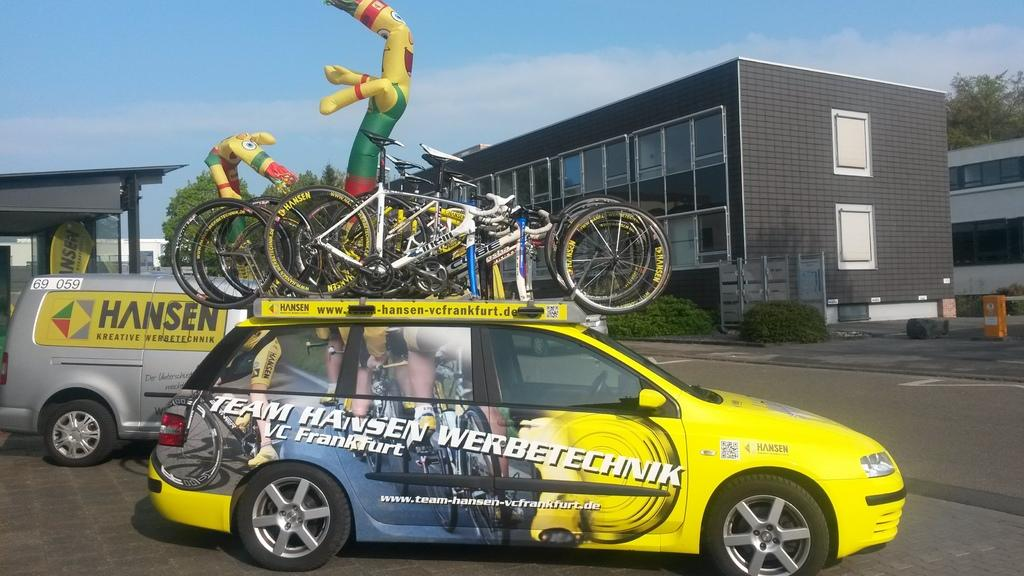<image>
Relay a brief, clear account of the picture shown. Two vehicles are covered with advertisement for Hansen. 